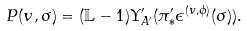<formula> <loc_0><loc_0><loc_500><loc_500>P ( v , \sigma ) = ( \mathbb { L } - 1 ) \Upsilon _ { A ^ { \prime } } ^ { \prime } ( \pi ^ { \prime } _ { \ast } \epsilon ^ { ( v , \phi ) } ( \sigma ) ) .</formula> 